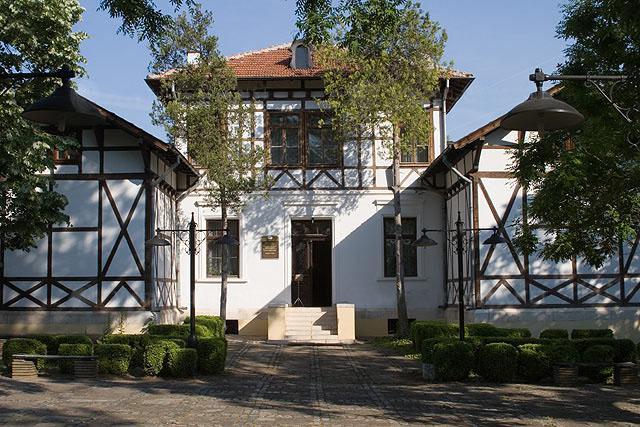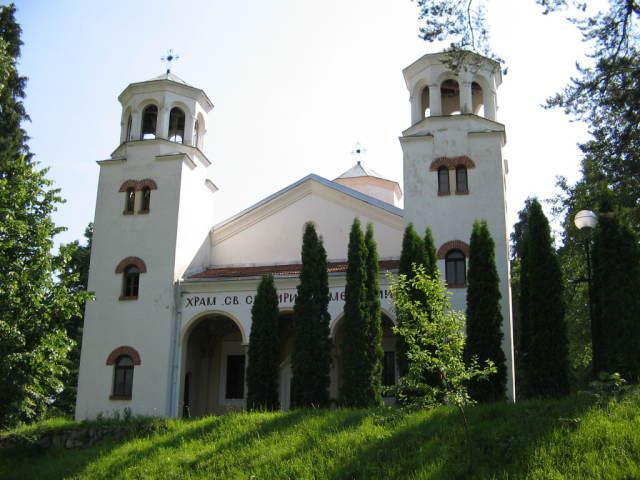The first image is the image on the left, the second image is the image on the right. For the images displayed, is the sentence "There are three windows on above the main door of a cathedral." factually correct? Answer yes or no. No. The first image is the image on the left, the second image is the image on the right. Considering the images on both sides, is "One building features three arches topped by a circle over the main archway entrance." valid? Answer yes or no. No. 